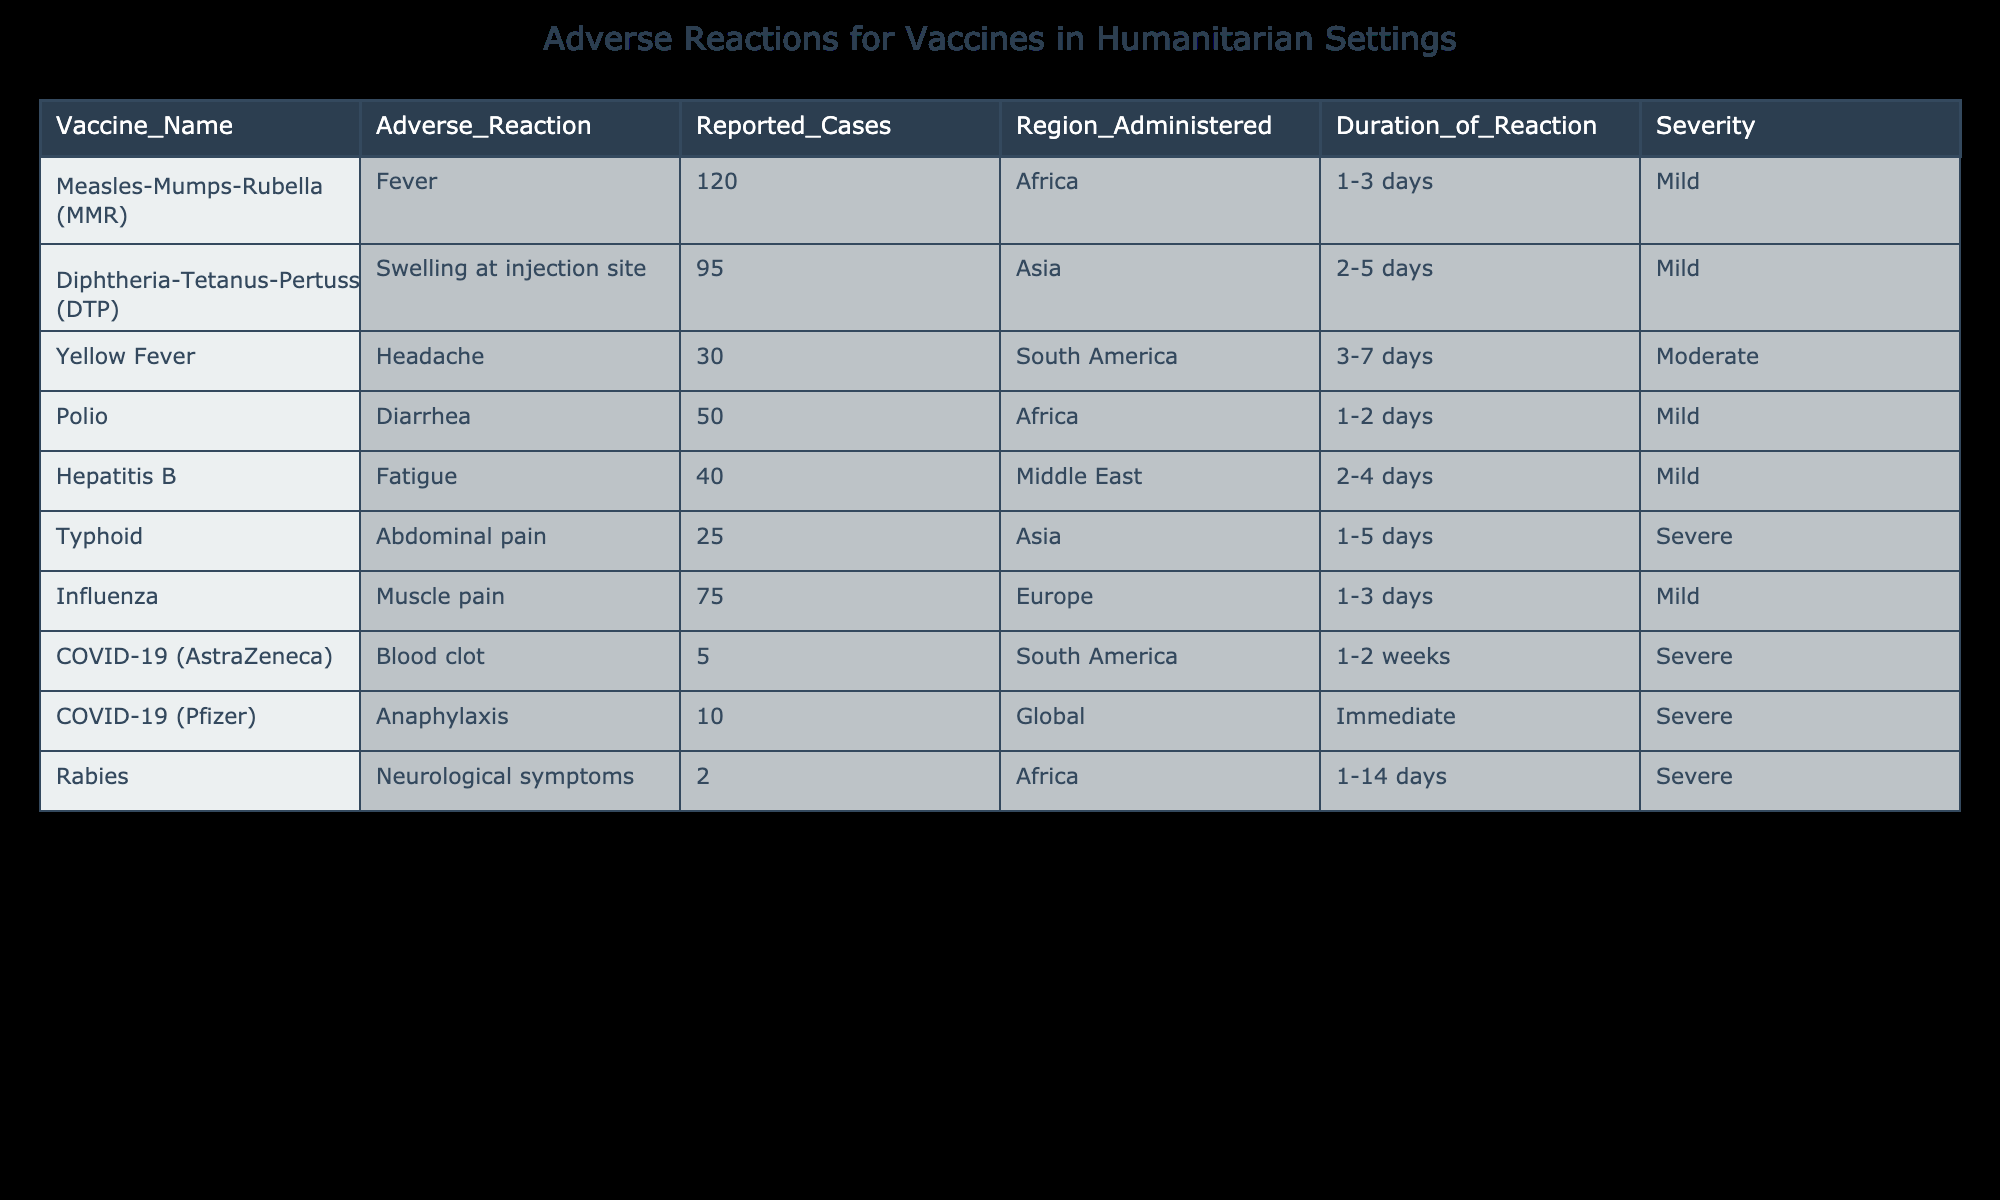What is the most reported adverse reaction for the Measles-Mumps-Rubella vaccine? The table shows that the most reported adverse reaction for the Measles-Mumps-Rubella (MMR) vaccine is Fever, with a total of 120 reported cases.
Answer: Fever How many adverse reactions were reported for the Diphtheria-Tetanus-Pertussis vaccine? According to the table, the Diphtheria-Tetanus-Pertussis (DTP) vaccine had 95 reported cases of adverse reactions.
Answer: 95 Is the fatigue reported for the Hepatitis B vaccine considered severe? The table indicates that the duration of the reaction for the Hepatitis B vaccine is Mild, which means it is not considered severe.
Answer: No What is the total number of reported cases for vaccines administered in Asia? By looking at the table, the vaccines administered in Asia and their reported cases are: Diphtheria-Tetanus-Pertussis (95), and Typhoid (25). Adding these gives a total of 95 + 25 = 120 reported cases.
Answer: 120 Which region had the highest severity level reported for adverse reactions, and what is the reaction? The region with the highest severity level reported for adverse reactions is the Global region, which has Anaphylaxis for the COVID-19 (Pfizer) vaccine marked as Severe.
Answer: Global, Anaphylaxis What is the average number of reported cases for adverse reactions in South America? In South America, the reported cases for Yellow Fever (30) and COVID-19 (AstraZeneca) (5) can be averaged. The total is 30 + 5 = 35 and there are 2 vaccines, so the average is 35/2 = 17.5.
Answer: 17.5 Are the neurological symptoms from the Rabies vaccine reported to last longer than 7 days? Referring to the data, the Rabies vaccine reports Neurological symptoms lasting from 1 to 14 days, which is longer than 7 days.
Answer: Yes How many adverse reactions were reported as moderate in severity? According to the table, the only reported adverse reaction classified as Moderate is the Headache from the Yellow Fever vaccine, totaling 30 cases.
Answer: 30 Was there any vaccine that reported fewer than 10 cases of adverse reactions? The table indicates that the Rabies vaccine reported only 2 cases of adverse reactions, which is fewer than 10.
Answer: Yes 